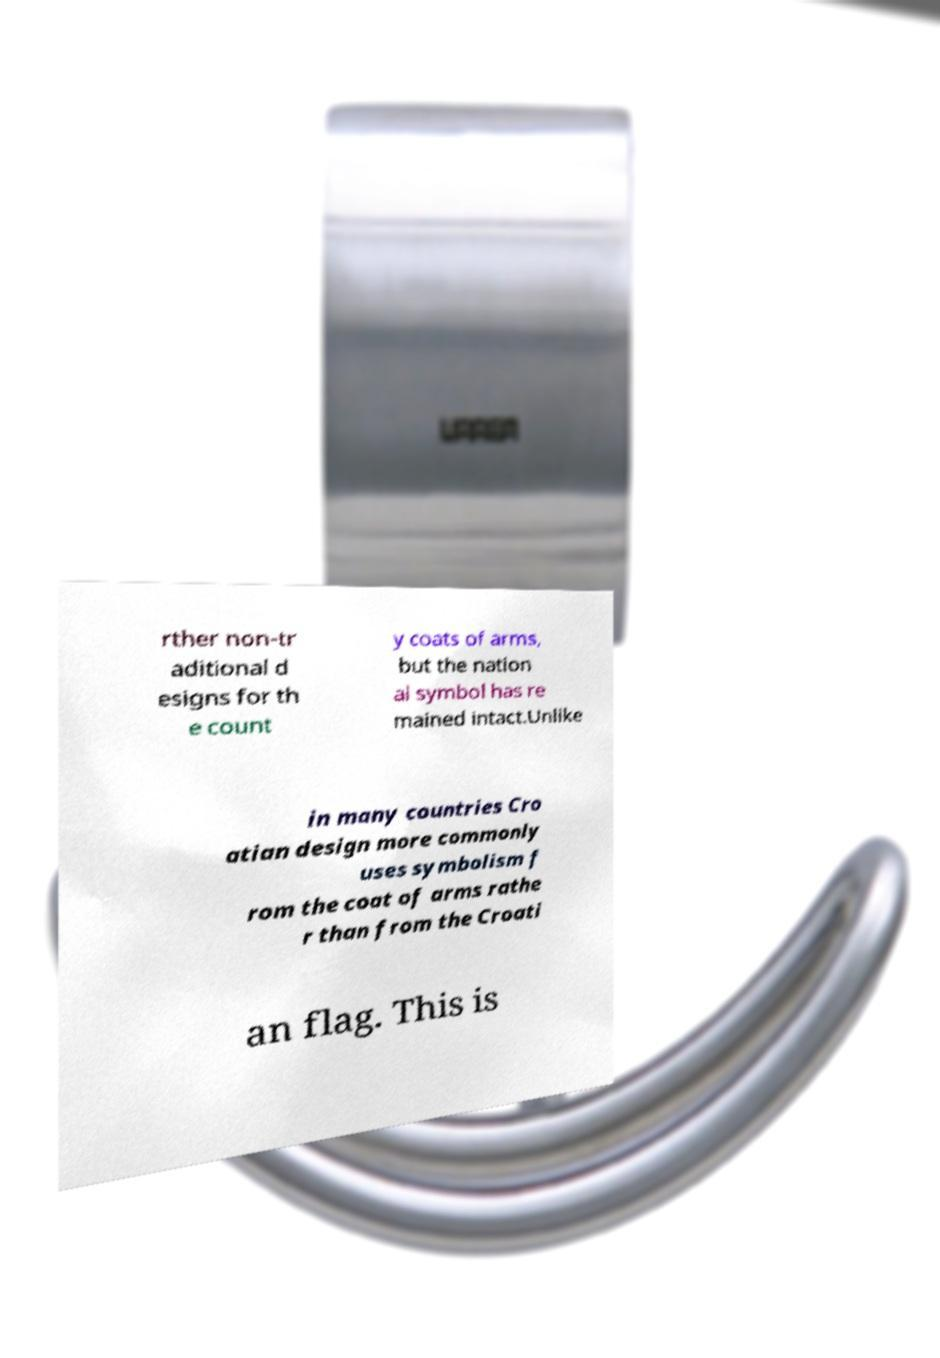Could you assist in decoding the text presented in this image and type it out clearly? rther non-tr aditional d esigns for th e count y coats of arms, but the nation al symbol has re mained intact.Unlike in many countries Cro atian design more commonly uses symbolism f rom the coat of arms rathe r than from the Croati an flag. This is 